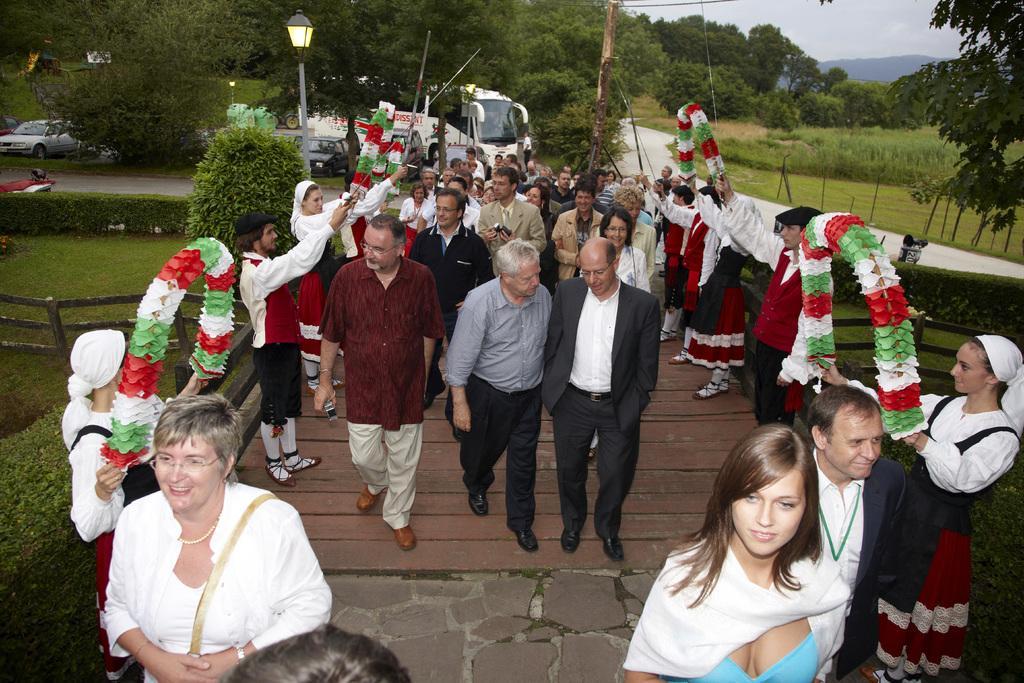Can you describe this image briefly? In the image in the center we can see a group of people were standing and few people were holding garlands. In the background we can see the sky,trees,plants,grass,vehicles,poles etc. 